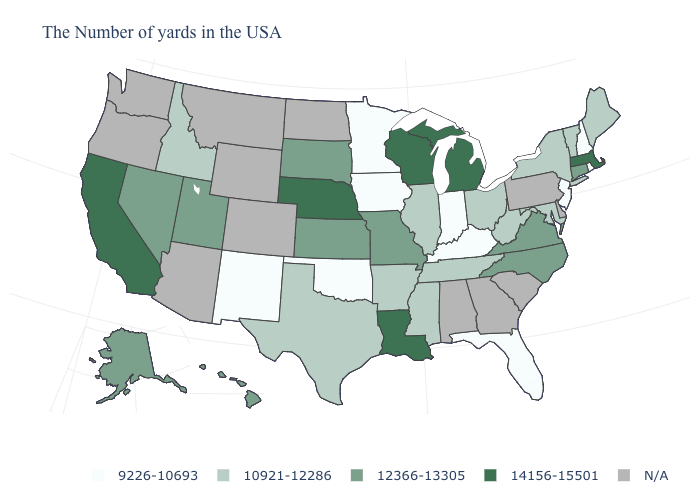Is the legend a continuous bar?
Write a very short answer. No. Among the states that border Rhode Island , which have the lowest value?
Answer briefly. Connecticut. Does the first symbol in the legend represent the smallest category?
Quick response, please. Yes. Which states have the lowest value in the USA?
Concise answer only. Rhode Island, New Hampshire, New Jersey, Florida, Kentucky, Indiana, Minnesota, Iowa, Oklahoma, New Mexico. What is the value of Indiana?
Answer briefly. 9226-10693. Among the states that border Illinois , which have the highest value?
Keep it brief. Wisconsin. Does Maryland have the highest value in the South?
Short answer required. No. Name the states that have a value in the range 9226-10693?
Keep it brief. Rhode Island, New Hampshire, New Jersey, Florida, Kentucky, Indiana, Minnesota, Iowa, Oklahoma, New Mexico. What is the value of South Dakota?
Write a very short answer. 12366-13305. Among the states that border Illinois , which have the lowest value?
Quick response, please. Kentucky, Indiana, Iowa. What is the value of Wisconsin?
Keep it brief. 14156-15501. What is the highest value in states that border Nevada?
Answer briefly. 14156-15501. Does the map have missing data?
Give a very brief answer. Yes. Name the states that have a value in the range 10921-12286?
Answer briefly. Maine, Vermont, New York, Maryland, West Virginia, Ohio, Tennessee, Illinois, Mississippi, Arkansas, Texas, Idaho. 